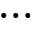Convert formula to latex. <formula><loc_0><loc_0><loc_500><loc_500>\dots</formula> 